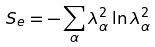Convert formula to latex. <formula><loc_0><loc_0><loc_500><loc_500>S _ { e } = - \sum _ { \alpha } \lambda _ { \alpha } ^ { 2 } \ln \lambda _ { \alpha } ^ { 2 }</formula> 